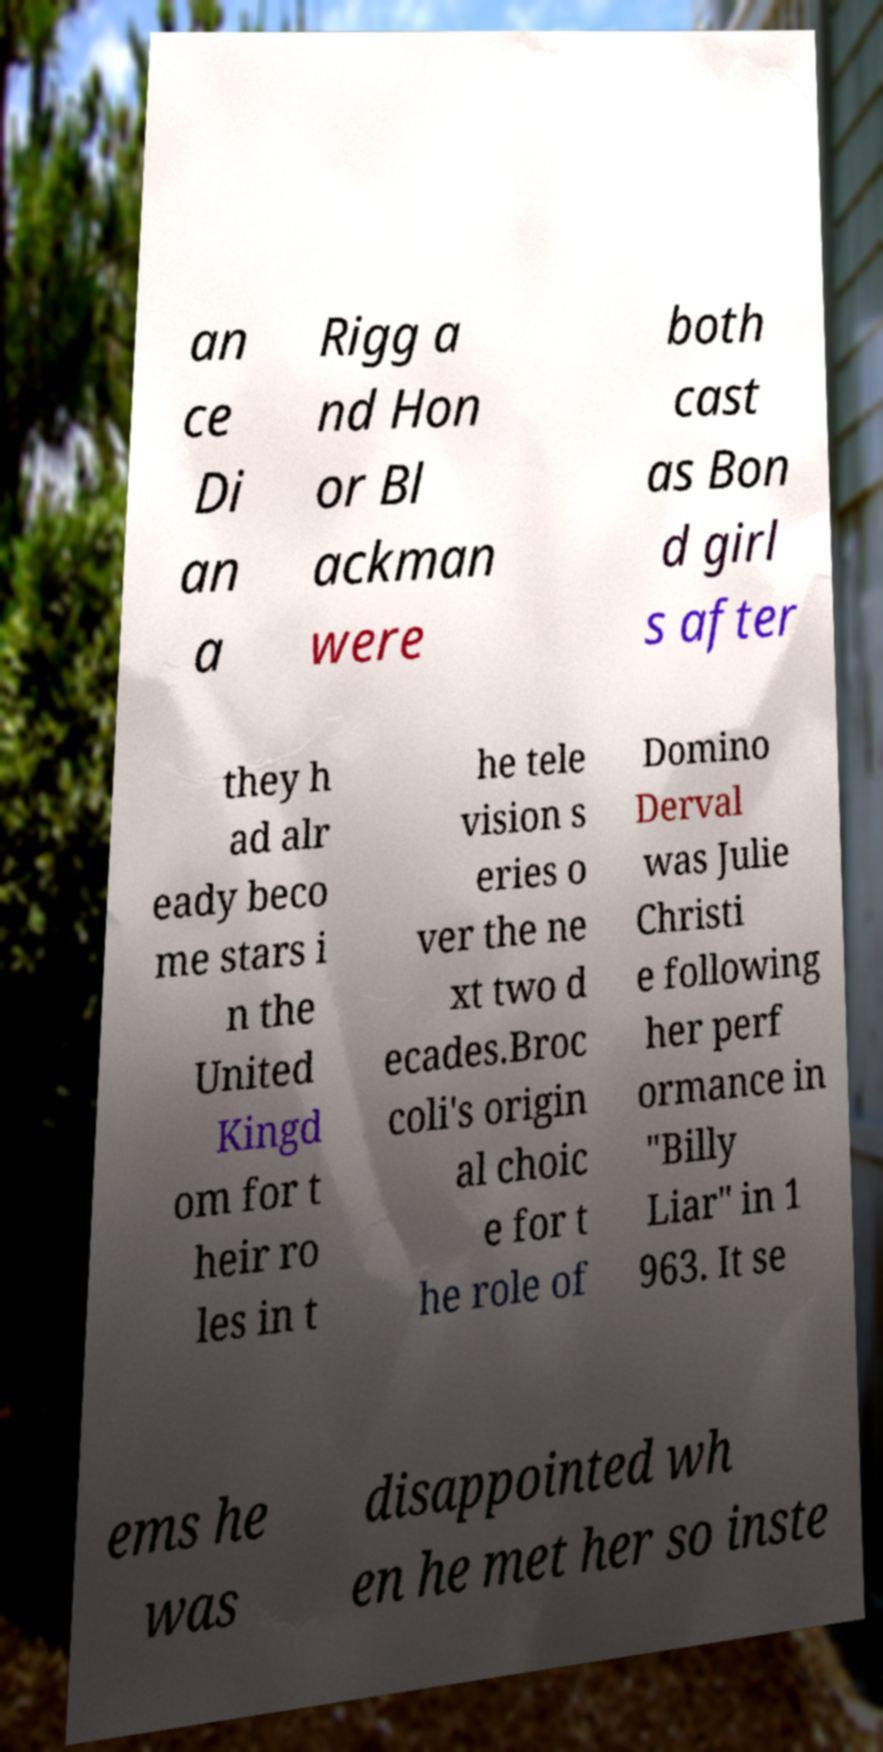Can you read and provide the text displayed in the image?This photo seems to have some interesting text. Can you extract and type it out for me? an ce Di an a Rigg a nd Hon or Bl ackman were both cast as Bon d girl s after they h ad alr eady beco me stars i n the United Kingd om for t heir ro les in t he tele vision s eries o ver the ne xt two d ecades.Broc coli's origin al choic e for t he role of Domino Derval was Julie Christi e following her perf ormance in "Billy Liar" in 1 963. It se ems he was disappointed wh en he met her so inste 